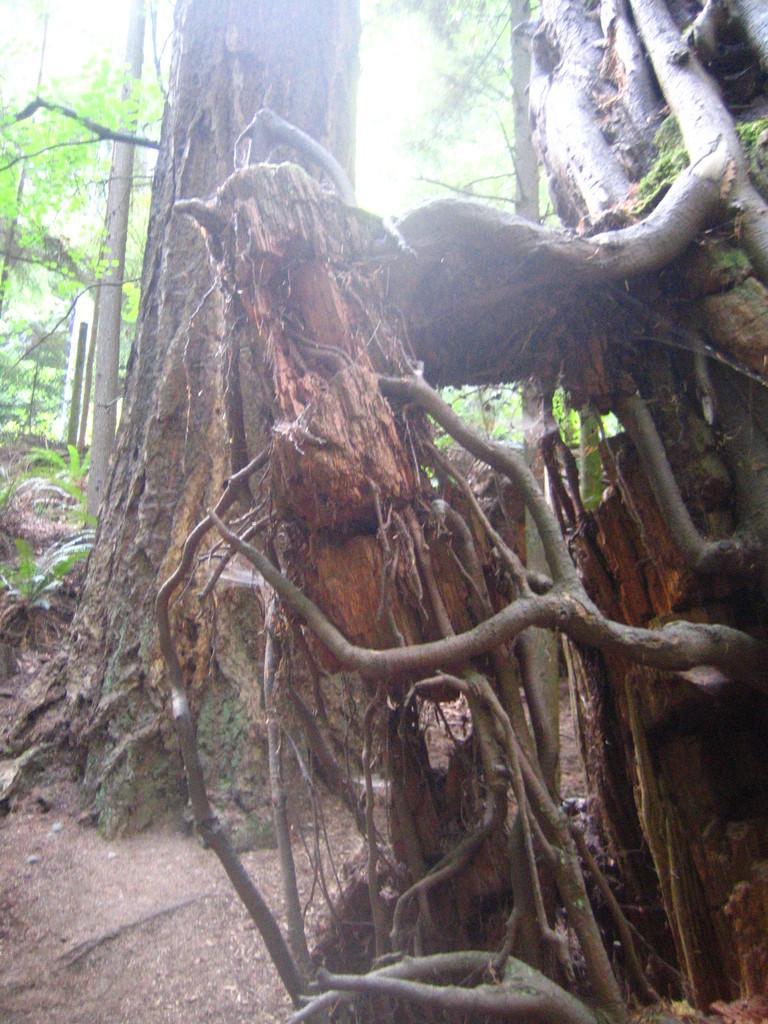Could you give a brief overview of what you see in this image? In this picture there is a dry roots of the tree. In the background we can see tree trunk and some green Leaves. 